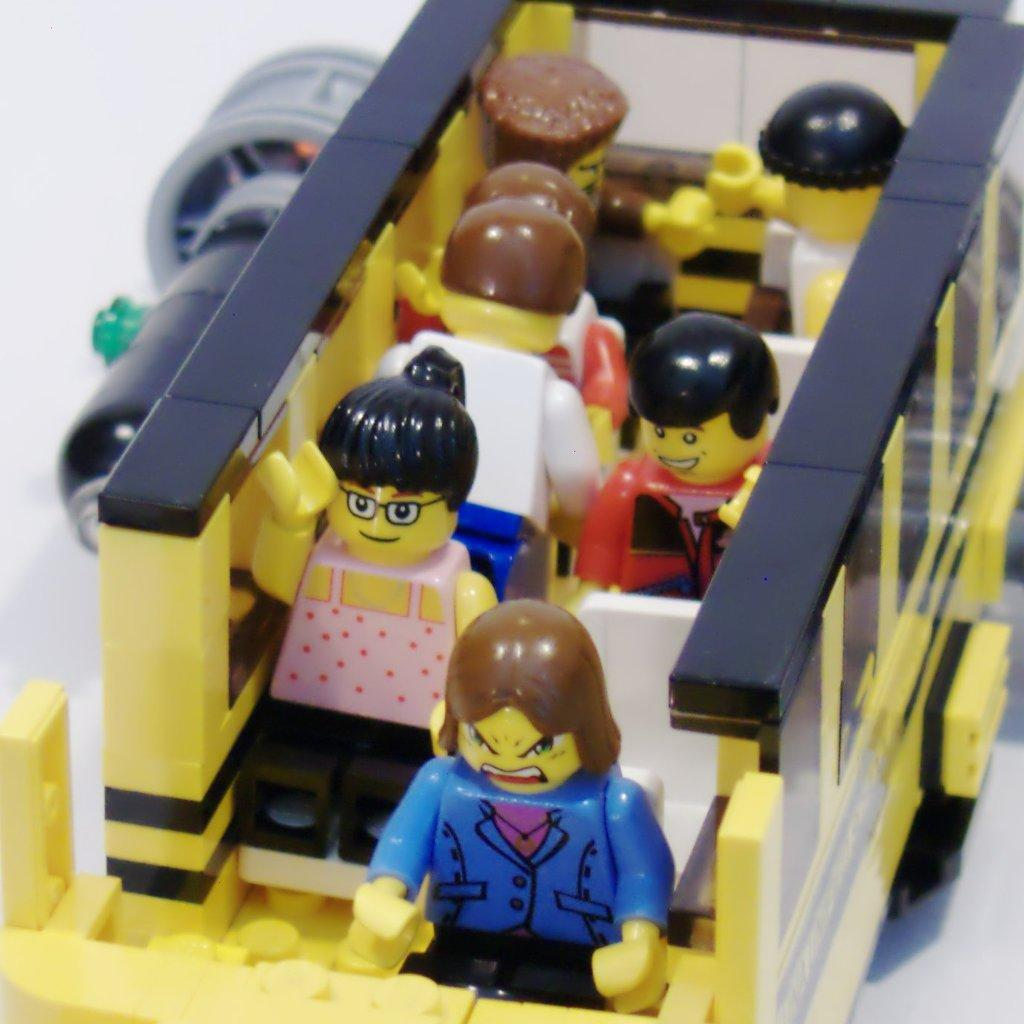What type of toy is the main subject in the image? There is a yellow bus toy in the image. Are there any other toys present in the image? Yes, there are toy people in the image. What is the color of the surface on which the toys are placed? The yellow bus toy and toy people are placed on a white surface. Can you describe the object on the left side of the image? Unfortunately, the facts provided do not give any information about the object on the left side of the image. How does the glove help the toy people in the image? There is no glove present in the image, so it cannot help the toy people. What is the process of digestion for the string in the image? There is no string present in the image, so there is no digestion process to discuss. 